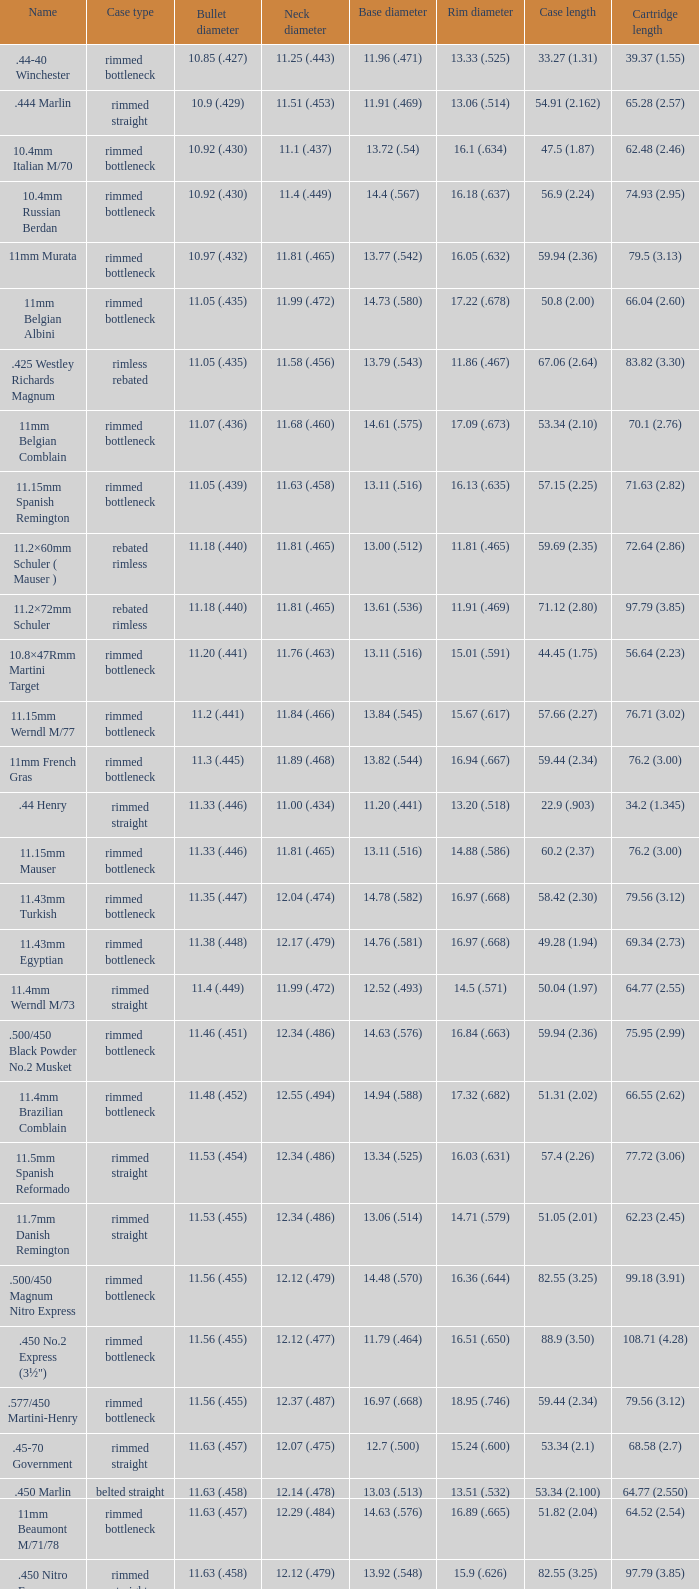For a neck diameter of 12.17 (.479), what is the corresponding bullet diameter? 11.38 (.448). 